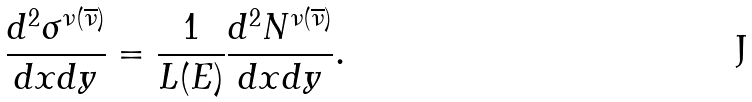<formula> <loc_0><loc_0><loc_500><loc_500>\frac { d ^ { 2 } \sigma ^ { \nu ( \overline { \nu } ) } } { d x d y } = \frac { 1 } { L ( E ) } \frac { d ^ { 2 } N ^ { \nu ( \overline { \nu } ) } } { d x d y } .</formula> 